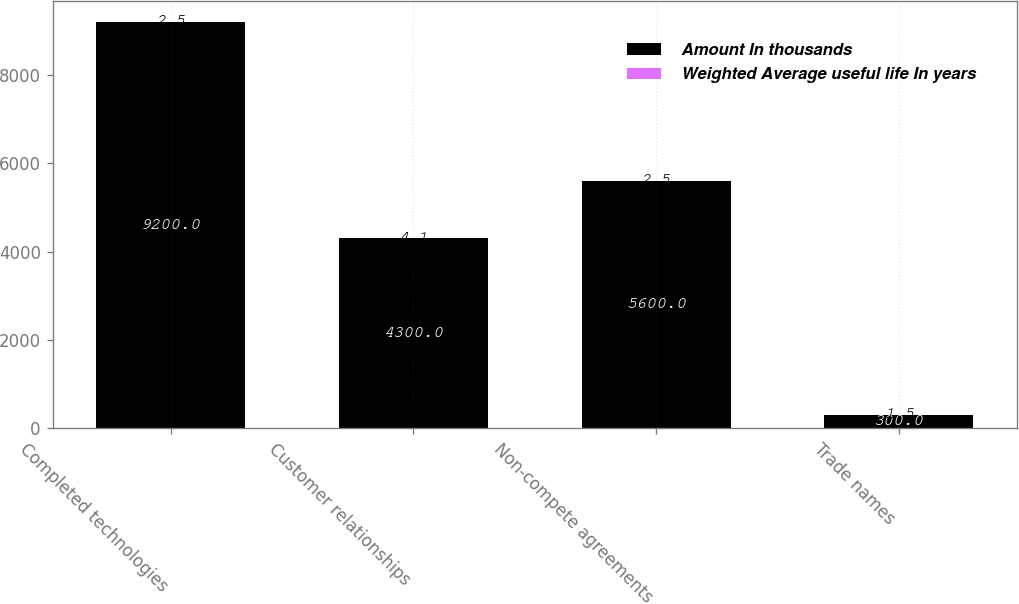Convert chart. <chart><loc_0><loc_0><loc_500><loc_500><stacked_bar_chart><ecel><fcel>Completed technologies<fcel>Customer relationships<fcel>Non-compete agreements<fcel>Trade names<nl><fcel>Amount In thousands<fcel>9200<fcel>4300<fcel>5600<fcel>300<nl><fcel>Weighted Average useful life In years<fcel>2.5<fcel>4.1<fcel>2.5<fcel>1.5<nl></chart> 